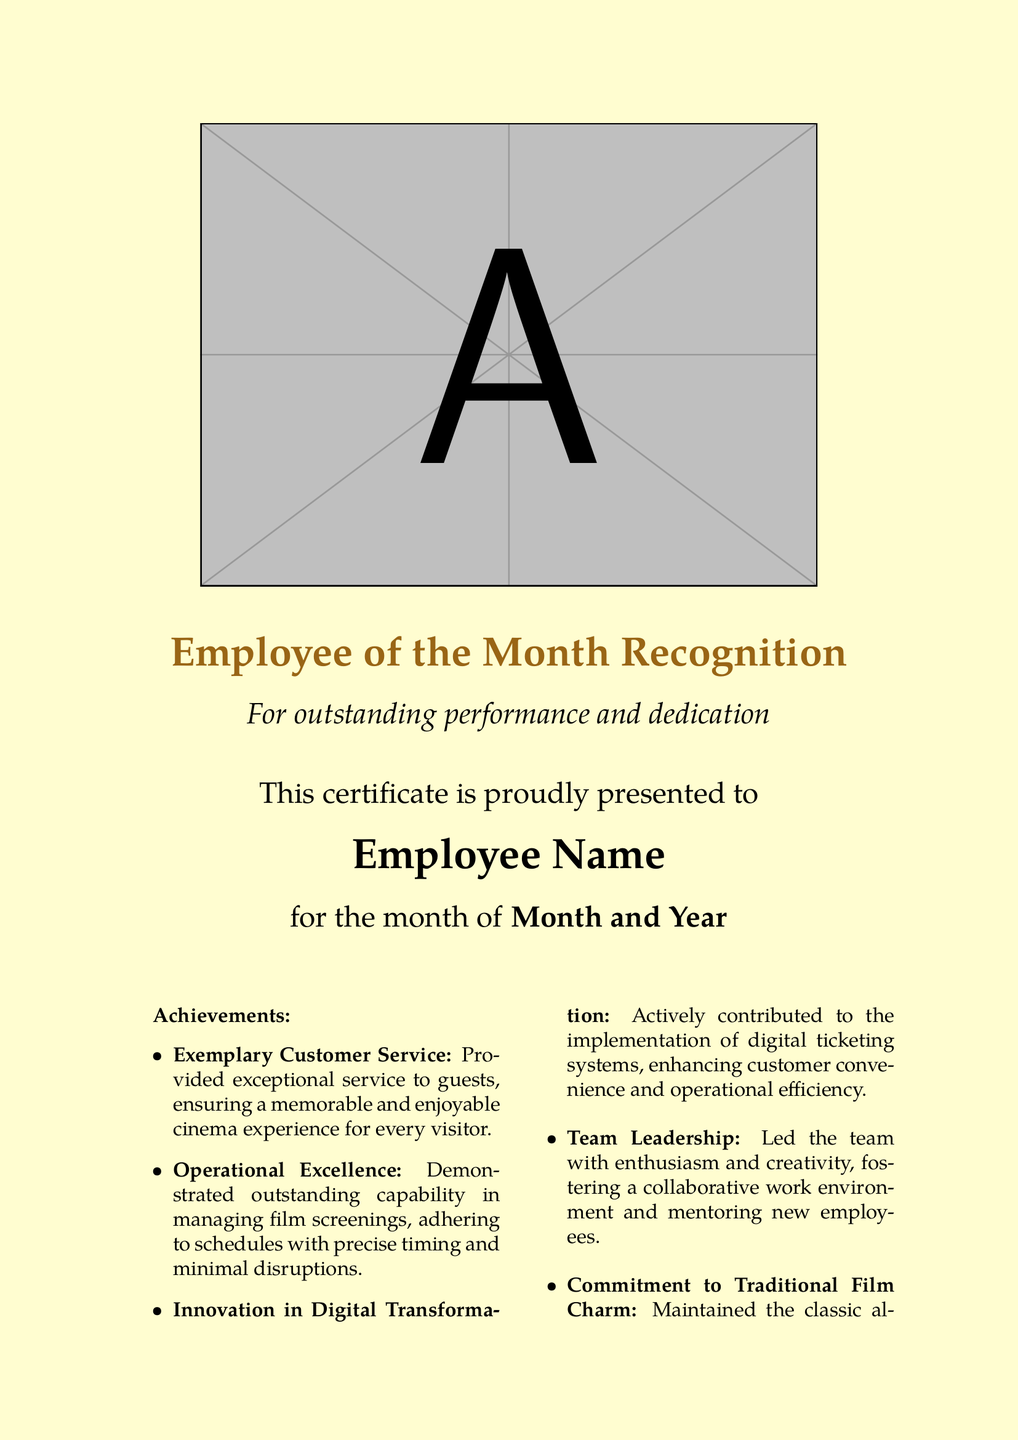What is the title of the certificate? The title of the certificate is prominently displayed at the top of the document, reading "Employee of the Month Recognition."
Answer: Employee of the Month Recognition Who is the recipient of the certificate? The recipient's name is indicated in a designated area for the employee's name in the document.
Answer: Employee Name What month and year is the recognition for? The month and year are specified in a sentence indicating for which time the award is issued.
Answer: Month and Year How many achievements are listed in the document? The achievements itemized in the document are counted to provide this information.
Answer: Five What achievement mentions customer service? This achievement specifically highlights excellent service provided to guests.
Answer: Exemplary Customer Service Which achievement focuses on digital systems? The achievement that discusses contributions to enhancing customer convenience through technology refers to the digital ticketing system.
Answer: Innovation in Digital Transformation What initiative did the employee lead that benefits the team? This initiative refers to leadership and fostering a positive work environment among employees.
Answer: Team Leadership What characteristic of cinema does the certificate commend? This refers to the preservation of the traditional presentation style, which evokes nostalgia.
Answer: Commitment to Traditional Film Charm Who signs the certificate? The document specifies who is responsible for signing, in this case, the cinema manager.
Answer: Cinema Manager's Signature 